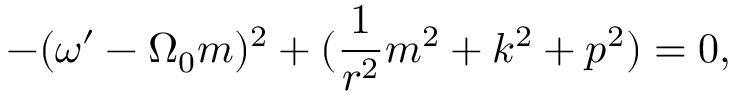<formula> <loc_0><loc_0><loc_500><loc_500>- ( \omega ^ { \prime } - \Omega _ { 0 } m ) ^ { 2 } + ( \frac { 1 } { r ^ { 2 } } m ^ { 2 } + k ^ { 2 } + p ^ { 2 } ) = 0 ,</formula> 